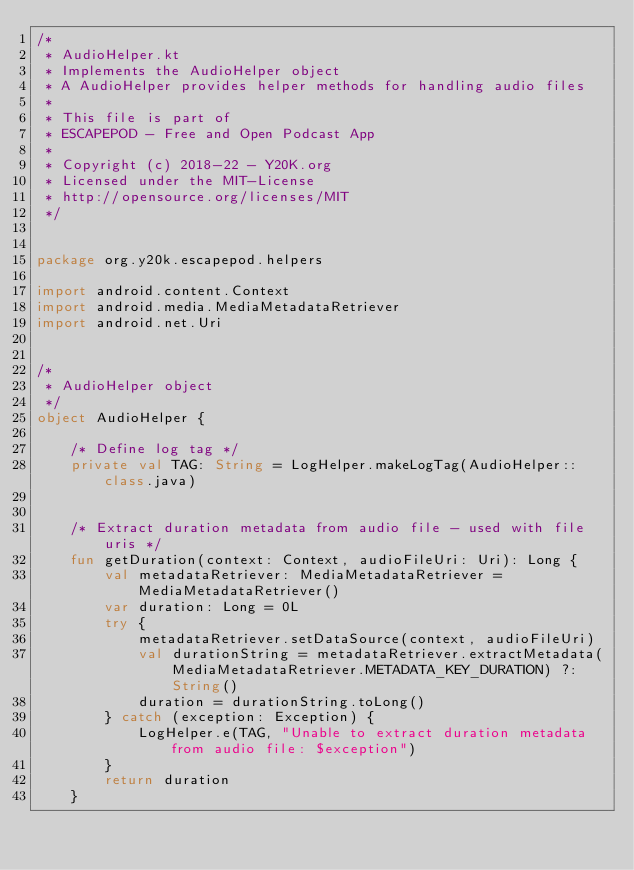<code> <loc_0><loc_0><loc_500><loc_500><_Kotlin_>/*
 * AudioHelper.kt
 * Implements the AudioHelper object
 * A AudioHelper provides helper methods for handling audio files
 *
 * This file is part of
 * ESCAPEPOD - Free and Open Podcast App
 *
 * Copyright (c) 2018-22 - Y20K.org
 * Licensed under the MIT-License
 * http://opensource.org/licenses/MIT
 */


package org.y20k.escapepod.helpers

import android.content.Context
import android.media.MediaMetadataRetriever
import android.net.Uri


/*
 * AudioHelper object
 */
object AudioHelper {

    /* Define log tag */
    private val TAG: String = LogHelper.makeLogTag(AudioHelper::class.java)


    /* Extract duration metadata from audio file - used with file uris */
    fun getDuration(context: Context, audioFileUri: Uri): Long {
        val metadataRetriever: MediaMetadataRetriever = MediaMetadataRetriever()
        var duration: Long = 0L
        try {
            metadataRetriever.setDataSource(context, audioFileUri)
            val durationString = metadataRetriever.extractMetadata(MediaMetadataRetriever.METADATA_KEY_DURATION) ?: String()
            duration = durationString.toLong()
        } catch (exception: Exception) {
            LogHelper.e(TAG, "Unable to extract duration metadata from audio file: $exception")
        }
        return duration
    }

</code> 